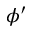<formula> <loc_0><loc_0><loc_500><loc_500>\phi ^ { \prime }</formula> 